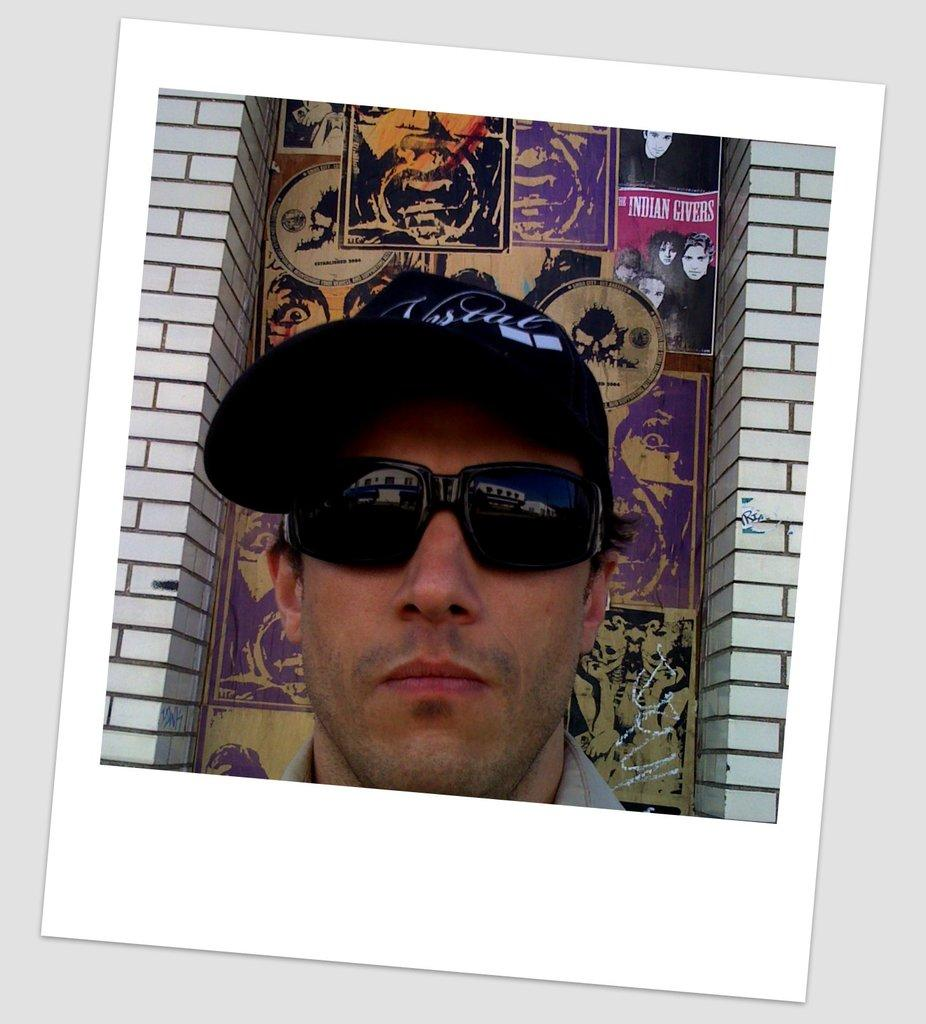What is the main subject of the image? There is a photograph of a man in the image. What color is the giraffe standing next to the man in the image? There is no giraffe present in the image; it only features a photograph of a man. 